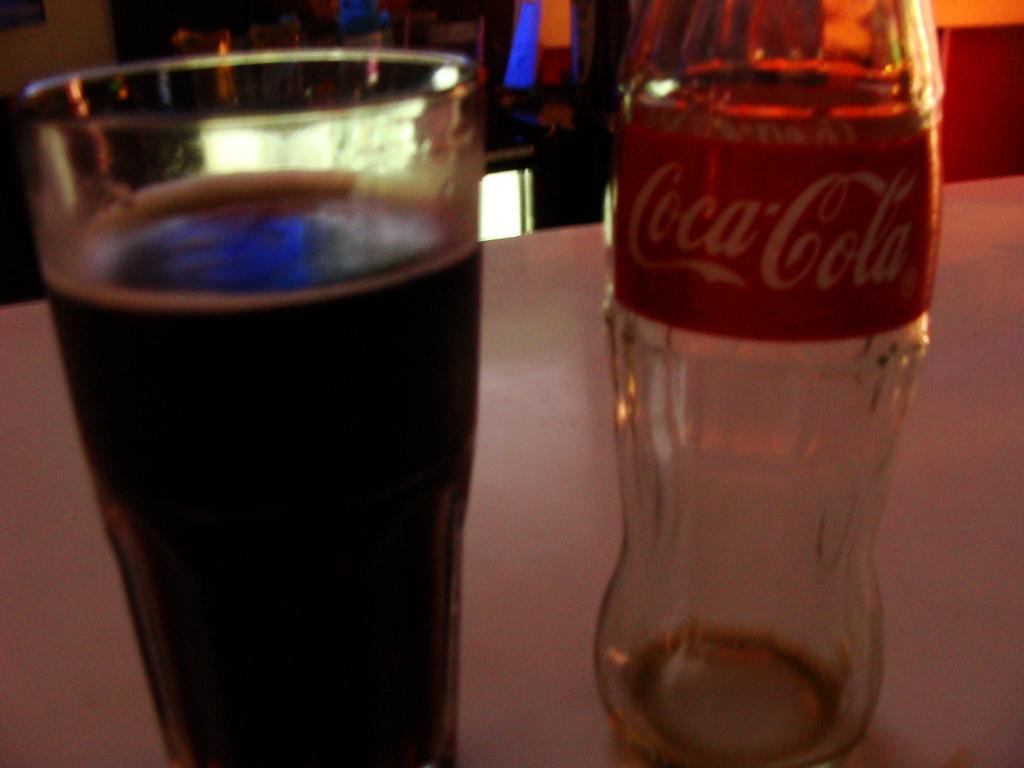What type of beverage container is in the image? There is a coca-cola bottle in the image. What else can be seen in the image besides the bottle? There is a glass of liquid in the image. Where are the bottle and the glass located? Both the bottle and the glass are placed on a table. What is the color of the table? The table is white in color. What type of building is visible in the image? There is no building visible in the image; it only features a coca-cola bottle, a glass of liquid, and a table. How much sand can be seen in the image? There is no sand present in the image. 